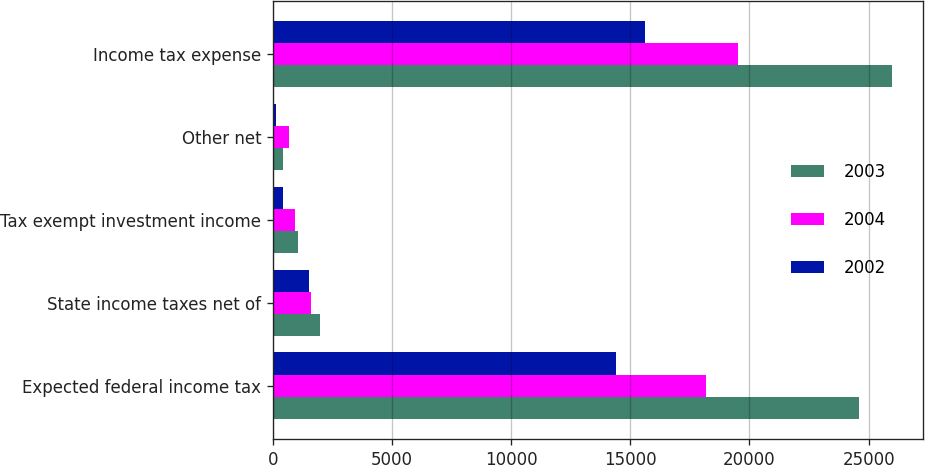<chart> <loc_0><loc_0><loc_500><loc_500><stacked_bar_chart><ecel><fcel>Expected federal income tax<fcel>State income taxes net of<fcel>Tax exempt investment income<fcel>Other net<fcel>Income tax expense<nl><fcel>2003<fcel>24600<fcel>1975<fcel>1030<fcel>430<fcel>25975<nl><fcel>2004<fcel>18163<fcel>1602<fcel>916<fcel>655<fcel>19504<nl><fcel>2002<fcel>14398<fcel>1520<fcel>411<fcel>124<fcel>15631<nl></chart> 